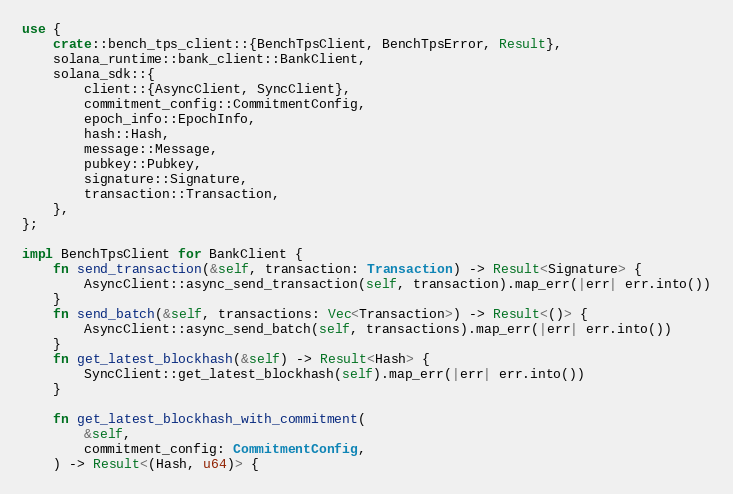Convert code to text. <code><loc_0><loc_0><loc_500><loc_500><_Rust_>use {
    crate::bench_tps_client::{BenchTpsClient, BenchTpsError, Result},
    solana_runtime::bank_client::BankClient,
    solana_sdk::{
        client::{AsyncClient, SyncClient},
        commitment_config::CommitmentConfig,
        epoch_info::EpochInfo,
        hash::Hash,
        message::Message,
        pubkey::Pubkey,
        signature::Signature,
        transaction::Transaction,
    },
};

impl BenchTpsClient for BankClient {
    fn send_transaction(&self, transaction: Transaction) -> Result<Signature> {
        AsyncClient::async_send_transaction(self, transaction).map_err(|err| err.into())
    }
    fn send_batch(&self, transactions: Vec<Transaction>) -> Result<()> {
        AsyncClient::async_send_batch(self, transactions).map_err(|err| err.into())
    }
    fn get_latest_blockhash(&self) -> Result<Hash> {
        SyncClient::get_latest_blockhash(self).map_err(|err| err.into())
    }

    fn get_latest_blockhash_with_commitment(
        &self,
        commitment_config: CommitmentConfig,
    ) -> Result<(Hash, u64)> {</code> 